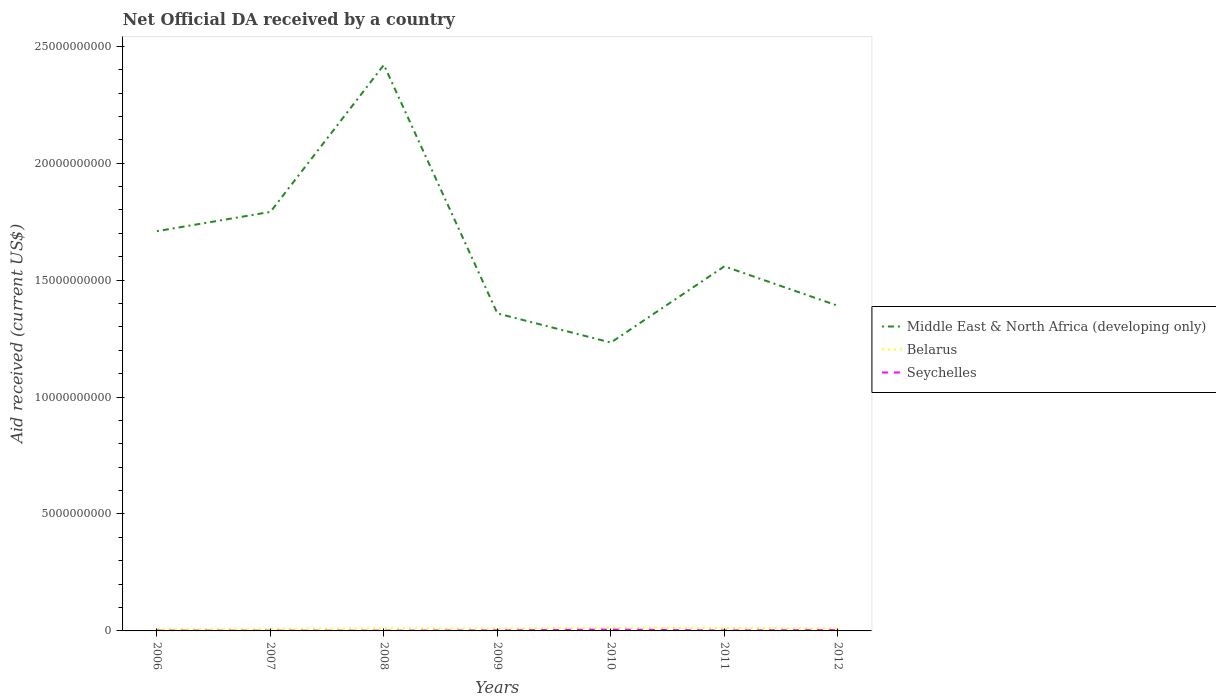How many different coloured lines are there?
Provide a succinct answer. 3. Is the number of lines equal to the number of legend labels?
Ensure brevity in your answer.  Yes. Across all years, what is the maximum net official development assistance aid received in Belarus?
Ensure brevity in your answer.  7.65e+07. What is the total net official development assistance aid received in Belarus in the graph?
Provide a short and direct response. 7.15e+06. What is the difference between the highest and the second highest net official development assistance aid received in Middle East & North Africa (developing only)?
Your answer should be compact. 1.19e+1. Is the net official development assistance aid received in Belarus strictly greater than the net official development assistance aid received in Seychelles over the years?
Make the answer very short. No. What is the difference between two consecutive major ticks on the Y-axis?
Your response must be concise. 5.00e+09. Are the values on the major ticks of Y-axis written in scientific E-notation?
Make the answer very short. No. Does the graph contain any zero values?
Provide a succinct answer. No. How many legend labels are there?
Give a very brief answer. 3. How are the legend labels stacked?
Make the answer very short. Vertical. What is the title of the graph?
Provide a succinct answer. Net Official DA received by a country. Does "Iceland" appear as one of the legend labels in the graph?
Offer a very short reply. No. What is the label or title of the X-axis?
Keep it short and to the point. Years. What is the label or title of the Y-axis?
Your response must be concise. Aid received (current US$). What is the Aid received (current US$) of Middle East & North Africa (developing only) in 2006?
Keep it short and to the point. 1.71e+1. What is the Aid received (current US$) in Belarus in 2006?
Make the answer very short. 7.65e+07. What is the Aid received (current US$) in Seychelles in 2006?
Give a very brief answer. 1.36e+07. What is the Aid received (current US$) of Middle East & North Africa (developing only) in 2007?
Your answer should be compact. 1.79e+1. What is the Aid received (current US$) of Belarus in 2007?
Provide a short and direct response. 8.38e+07. What is the Aid received (current US$) of Seychelles in 2007?
Provide a succinct answer. 1.10e+07. What is the Aid received (current US$) of Middle East & North Africa (developing only) in 2008?
Provide a succinct answer. 2.42e+1. What is the Aid received (current US$) of Belarus in 2008?
Make the answer very short. 1.10e+08. What is the Aid received (current US$) of Seychelles in 2008?
Offer a terse response. 1.25e+07. What is the Aid received (current US$) of Middle East & North Africa (developing only) in 2009?
Your answer should be very brief. 1.36e+1. What is the Aid received (current US$) of Belarus in 2009?
Ensure brevity in your answer.  9.77e+07. What is the Aid received (current US$) of Seychelles in 2009?
Give a very brief answer. 2.28e+07. What is the Aid received (current US$) in Middle East & North Africa (developing only) in 2010?
Keep it short and to the point. 1.23e+1. What is the Aid received (current US$) in Belarus in 2010?
Keep it short and to the point. 1.38e+08. What is the Aid received (current US$) of Seychelles in 2010?
Keep it short and to the point. 5.60e+07. What is the Aid received (current US$) in Middle East & North Africa (developing only) in 2011?
Ensure brevity in your answer.  1.56e+1. What is the Aid received (current US$) in Belarus in 2011?
Your response must be concise. 1.26e+08. What is the Aid received (current US$) of Seychelles in 2011?
Offer a very short reply. 2.21e+07. What is the Aid received (current US$) of Middle East & North Africa (developing only) in 2012?
Your answer should be very brief. 1.39e+1. What is the Aid received (current US$) in Belarus in 2012?
Provide a short and direct response. 1.03e+08. What is the Aid received (current US$) in Seychelles in 2012?
Provide a succinct answer. 3.56e+07. Across all years, what is the maximum Aid received (current US$) of Middle East & North Africa (developing only)?
Provide a succinct answer. 2.42e+1. Across all years, what is the maximum Aid received (current US$) of Belarus?
Provide a short and direct response. 1.38e+08. Across all years, what is the maximum Aid received (current US$) in Seychelles?
Your answer should be very brief. 5.60e+07. Across all years, what is the minimum Aid received (current US$) of Middle East & North Africa (developing only)?
Your answer should be very brief. 1.23e+1. Across all years, what is the minimum Aid received (current US$) in Belarus?
Ensure brevity in your answer.  7.65e+07. Across all years, what is the minimum Aid received (current US$) of Seychelles?
Give a very brief answer. 1.10e+07. What is the total Aid received (current US$) of Middle East & North Africa (developing only) in the graph?
Your answer should be very brief. 1.15e+11. What is the total Aid received (current US$) of Belarus in the graph?
Ensure brevity in your answer.  7.36e+08. What is the total Aid received (current US$) in Seychelles in the graph?
Provide a succinct answer. 1.74e+08. What is the difference between the Aid received (current US$) of Middle East & North Africa (developing only) in 2006 and that in 2007?
Provide a succinct answer. -8.23e+08. What is the difference between the Aid received (current US$) in Belarus in 2006 and that in 2007?
Your response must be concise. -7.24e+06. What is the difference between the Aid received (current US$) of Seychelles in 2006 and that in 2007?
Offer a very short reply. 2.60e+06. What is the difference between the Aid received (current US$) in Middle East & North Africa (developing only) in 2006 and that in 2008?
Offer a terse response. -7.11e+09. What is the difference between the Aid received (current US$) of Belarus in 2006 and that in 2008?
Offer a very short reply. -3.39e+07. What is the difference between the Aid received (current US$) of Seychelles in 2006 and that in 2008?
Your response must be concise. 1.12e+06. What is the difference between the Aid received (current US$) of Middle East & North Africa (developing only) in 2006 and that in 2009?
Your response must be concise. 3.52e+09. What is the difference between the Aid received (current US$) of Belarus in 2006 and that in 2009?
Keep it short and to the point. -2.11e+07. What is the difference between the Aid received (current US$) of Seychelles in 2006 and that in 2009?
Provide a short and direct response. -9.12e+06. What is the difference between the Aid received (current US$) in Middle East & North Africa (developing only) in 2006 and that in 2010?
Ensure brevity in your answer.  4.76e+09. What is the difference between the Aid received (current US$) of Belarus in 2006 and that in 2010?
Make the answer very short. -6.16e+07. What is the difference between the Aid received (current US$) of Seychelles in 2006 and that in 2010?
Make the answer very short. -4.24e+07. What is the difference between the Aid received (current US$) in Middle East & North Africa (developing only) in 2006 and that in 2011?
Ensure brevity in your answer.  1.50e+09. What is the difference between the Aid received (current US$) of Belarus in 2006 and that in 2011?
Provide a succinct answer. -4.95e+07. What is the difference between the Aid received (current US$) of Seychelles in 2006 and that in 2011?
Provide a short and direct response. -8.46e+06. What is the difference between the Aid received (current US$) in Middle East & North Africa (developing only) in 2006 and that in 2012?
Your response must be concise. 3.19e+09. What is the difference between the Aid received (current US$) of Belarus in 2006 and that in 2012?
Give a very brief answer. -2.68e+07. What is the difference between the Aid received (current US$) of Seychelles in 2006 and that in 2012?
Keep it short and to the point. -2.19e+07. What is the difference between the Aid received (current US$) in Middle East & North Africa (developing only) in 2007 and that in 2008?
Offer a very short reply. -6.29e+09. What is the difference between the Aid received (current US$) of Belarus in 2007 and that in 2008?
Provide a succinct answer. -2.67e+07. What is the difference between the Aid received (current US$) in Seychelles in 2007 and that in 2008?
Ensure brevity in your answer.  -1.48e+06. What is the difference between the Aid received (current US$) of Middle East & North Africa (developing only) in 2007 and that in 2009?
Make the answer very short. 4.34e+09. What is the difference between the Aid received (current US$) of Belarus in 2007 and that in 2009?
Your answer should be compact. -1.39e+07. What is the difference between the Aid received (current US$) of Seychelles in 2007 and that in 2009?
Give a very brief answer. -1.17e+07. What is the difference between the Aid received (current US$) in Middle East & North Africa (developing only) in 2007 and that in 2010?
Offer a terse response. 5.59e+09. What is the difference between the Aid received (current US$) in Belarus in 2007 and that in 2010?
Keep it short and to the point. -5.44e+07. What is the difference between the Aid received (current US$) in Seychelles in 2007 and that in 2010?
Give a very brief answer. -4.50e+07. What is the difference between the Aid received (current US$) of Middle East & North Africa (developing only) in 2007 and that in 2011?
Give a very brief answer. 2.33e+09. What is the difference between the Aid received (current US$) of Belarus in 2007 and that in 2011?
Your answer should be compact. -4.22e+07. What is the difference between the Aid received (current US$) in Seychelles in 2007 and that in 2011?
Offer a very short reply. -1.11e+07. What is the difference between the Aid received (current US$) in Middle East & North Africa (developing only) in 2007 and that in 2012?
Keep it short and to the point. 4.01e+09. What is the difference between the Aid received (current US$) of Belarus in 2007 and that in 2012?
Your answer should be compact. -1.95e+07. What is the difference between the Aid received (current US$) in Seychelles in 2007 and that in 2012?
Offer a very short reply. -2.45e+07. What is the difference between the Aid received (current US$) of Middle East & North Africa (developing only) in 2008 and that in 2009?
Keep it short and to the point. 1.06e+1. What is the difference between the Aid received (current US$) of Belarus in 2008 and that in 2009?
Your response must be concise. 1.28e+07. What is the difference between the Aid received (current US$) in Seychelles in 2008 and that in 2009?
Offer a terse response. -1.02e+07. What is the difference between the Aid received (current US$) in Middle East & North Africa (developing only) in 2008 and that in 2010?
Give a very brief answer. 1.19e+1. What is the difference between the Aid received (current US$) of Belarus in 2008 and that in 2010?
Your response must be concise. -2.77e+07. What is the difference between the Aid received (current US$) of Seychelles in 2008 and that in 2010?
Provide a short and direct response. -4.35e+07. What is the difference between the Aid received (current US$) of Middle East & North Africa (developing only) in 2008 and that in 2011?
Offer a terse response. 8.62e+09. What is the difference between the Aid received (current US$) in Belarus in 2008 and that in 2011?
Your answer should be compact. -1.56e+07. What is the difference between the Aid received (current US$) of Seychelles in 2008 and that in 2011?
Provide a succinct answer. -9.58e+06. What is the difference between the Aid received (current US$) of Middle East & North Africa (developing only) in 2008 and that in 2012?
Offer a very short reply. 1.03e+1. What is the difference between the Aid received (current US$) in Belarus in 2008 and that in 2012?
Give a very brief answer. 7.15e+06. What is the difference between the Aid received (current US$) of Seychelles in 2008 and that in 2012?
Make the answer very short. -2.31e+07. What is the difference between the Aid received (current US$) in Middle East & North Africa (developing only) in 2009 and that in 2010?
Provide a short and direct response. 1.25e+09. What is the difference between the Aid received (current US$) of Belarus in 2009 and that in 2010?
Your response must be concise. -4.04e+07. What is the difference between the Aid received (current US$) in Seychelles in 2009 and that in 2010?
Keep it short and to the point. -3.33e+07. What is the difference between the Aid received (current US$) in Middle East & North Africa (developing only) in 2009 and that in 2011?
Offer a very short reply. -2.01e+09. What is the difference between the Aid received (current US$) of Belarus in 2009 and that in 2011?
Offer a terse response. -2.83e+07. What is the difference between the Aid received (current US$) in Middle East & North Africa (developing only) in 2009 and that in 2012?
Make the answer very short. -3.27e+08. What is the difference between the Aid received (current US$) in Belarus in 2009 and that in 2012?
Give a very brief answer. -5.61e+06. What is the difference between the Aid received (current US$) in Seychelles in 2009 and that in 2012?
Offer a terse response. -1.28e+07. What is the difference between the Aid received (current US$) in Middle East & North Africa (developing only) in 2010 and that in 2011?
Give a very brief answer. -3.26e+09. What is the difference between the Aid received (current US$) of Belarus in 2010 and that in 2011?
Keep it short and to the point. 1.21e+07. What is the difference between the Aid received (current US$) in Seychelles in 2010 and that in 2011?
Offer a very short reply. 3.39e+07. What is the difference between the Aid received (current US$) in Middle East & North Africa (developing only) in 2010 and that in 2012?
Keep it short and to the point. -1.57e+09. What is the difference between the Aid received (current US$) in Belarus in 2010 and that in 2012?
Your response must be concise. 3.48e+07. What is the difference between the Aid received (current US$) of Seychelles in 2010 and that in 2012?
Your response must be concise. 2.05e+07. What is the difference between the Aid received (current US$) of Middle East & North Africa (developing only) in 2011 and that in 2012?
Provide a short and direct response. 1.69e+09. What is the difference between the Aid received (current US$) in Belarus in 2011 and that in 2012?
Give a very brief answer. 2.27e+07. What is the difference between the Aid received (current US$) of Seychelles in 2011 and that in 2012?
Offer a very short reply. -1.35e+07. What is the difference between the Aid received (current US$) of Middle East & North Africa (developing only) in 2006 and the Aid received (current US$) of Belarus in 2007?
Keep it short and to the point. 1.70e+1. What is the difference between the Aid received (current US$) of Middle East & North Africa (developing only) in 2006 and the Aid received (current US$) of Seychelles in 2007?
Your answer should be very brief. 1.71e+1. What is the difference between the Aid received (current US$) of Belarus in 2006 and the Aid received (current US$) of Seychelles in 2007?
Provide a short and direct response. 6.55e+07. What is the difference between the Aid received (current US$) of Middle East & North Africa (developing only) in 2006 and the Aid received (current US$) of Belarus in 2008?
Offer a very short reply. 1.70e+1. What is the difference between the Aid received (current US$) of Middle East & North Africa (developing only) in 2006 and the Aid received (current US$) of Seychelles in 2008?
Keep it short and to the point. 1.71e+1. What is the difference between the Aid received (current US$) of Belarus in 2006 and the Aid received (current US$) of Seychelles in 2008?
Your answer should be very brief. 6.40e+07. What is the difference between the Aid received (current US$) of Middle East & North Africa (developing only) in 2006 and the Aid received (current US$) of Belarus in 2009?
Your response must be concise. 1.70e+1. What is the difference between the Aid received (current US$) in Middle East & North Africa (developing only) in 2006 and the Aid received (current US$) in Seychelles in 2009?
Offer a terse response. 1.71e+1. What is the difference between the Aid received (current US$) of Belarus in 2006 and the Aid received (current US$) of Seychelles in 2009?
Ensure brevity in your answer.  5.38e+07. What is the difference between the Aid received (current US$) in Middle East & North Africa (developing only) in 2006 and the Aid received (current US$) in Belarus in 2010?
Provide a succinct answer. 1.70e+1. What is the difference between the Aid received (current US$) of Middle East & North Africa (developing only) in 2006 and the Aid received (current US$) of Seychelles in 2010?
Provide a short and direct response. 1.70e+1. What is the difference between the Aid received (current US$) in Belarus in 2006 and the Aid received (current US$) in Seychelles in 2010?
Offer a terse response. 2.05e+07. What is the difference between the Aid received (current US$) of Middle East & North Africa (developing only) in 2006 and the Aid received (current US$) of Belarus in 2011?
Keep it short and to the point. 1.70e+1. What is the difference between the Aid received (current US$) of Middle East & North Africa (developing only) in 2006 and the Aid received (current US$) of Seychelles in 2011?
Give a very brief answer. 1.71e+1. What is the difference between the Aid received (current US$) of Belarus in 2006 and the Aid received (current US$) of Seychelles in 2011?
Make the answer very short. 5.44e+07. What is the difference between the Aid received (current US$) of Middle East & North Africa (developing only) in 2006 and the Aid received (current US$) of Belarus in 2012?
Offer a very short reply. 1.70e+1. What is the difference between the Aid received (current US$) in Middle East & North Africa (developing only) in 2006 and the Aid received (current US$) in Seychelles in 2012?
Your answer should be compact. 1.71e+1. What is the difference between the Aid received (current US$) of Belarus in 2006 and the Aid received (current US$) of Seychelles in 2012?
Give a very brief answer. 4.09e+07. What is the difference between the Aid received (current US$) of Middle East & North Africa (developing only) in 2007 and the Aid received (current US$) of Belarus in 2008?
Ensure brevity in your answer.  1.78e+1. What is the difference between the Aid received (current US$) in Middle East & North Africa (developing only) in 2007 and the Aid received (current US$) in Seychelles in 2008?
Provide a short and direct response. 1.79e+1. What is the difference between the Aid received (current US$) in Belarus in 2007 and the Aid received (current US$) in Seychelles in 2008?
Your answer should be very brief. 7.12e+07. What is the difference between the Aid received (current US$) of Middle East & North Africa (developing only) in 2007 and the Aid received (current US$) of Belarus in 2009?
Provide a succinct answer. 1.78e+1. What is the difference between the Aid received (current US$) of Middle East & North Africa (developing only) in 2007 and the Aid received (current US$) of Seychelles in 2009?
Your response must be concise. 1.79e+1. What is the difference between the Aid received (current US$) in Belarus in 2007 and the Aid received (current US$) in Seychelles in 2009?
Make the answer very short. 6.10e+07. What is the difference between the Aid received (current US$) of Middle East & North Africa (developing only) in 2007 and the Aid received (current US$) of Belarus in 2010?
Provide a short and direct response. 1.78e+1. What is the difference between the Aid received (current US$) in Middle East & North Africa (developing only) in 2007 and the Aid received (current US$) in Seychelles in 2010?
Offer a terse response. 1.79e+1. What is the difference between the Aid received (current US$) in Belarus in 2007 and the Aid received (current US$) in Seychelles in 2010?
Ensure brevity in your answer.  2.77e+07. What is the difference between the Aid received (current US$) in Middle East & North Africa (developing only) in 2007 and the Aid received (current US$) in Belarus in 2011?
Ensure brevity in your answer.  1.78e+1. What is the difference between the Aid received (current US$) in Middle East & North Africa (developing only) in 2007 and the Aid received (current US$) in Seychelles in 2011?
Provide a succinct answer. 1.79e+1. What is the difference between the Aid received (current US$) of Belarus in 2007 and the Aid received (current US$) of Seychelles in 2011?
Your answer should be compact. 6.17e+07. What is the difference between the Aid received (current US$) in Middle East & North Africa (developing only) in 2007 and the Aid received (current US$) in Belarus in 2012?
Provide a short and direct response. 1.78e+1. What is the difference between the Aid received (current US$) of Middle East & North Africa (developing only) in 2007 and the Aid received (current US$) of Seychelles in 2012?
Make the answer very short. 1.79e+1. What is the difference between the Aid received (current US$) in Belarus in 2007 and the Aid received (current US$) in Seychelles in 2012?
Provide a succinct answer. 4.82e+07. What is the difference between the Aid received (current US$) in Middle East & North Africa (developing only) in 2008 and the Aid received (current US$) in Belarus in 2009?
Offer a very short reply. 2.41e+1. What is the difference between the Aid received (current US$) of Middle East & North Africa (developing only) in 2008 and the Aid received (current US$) of Seychelles in 2009?
Provide a succinct answer. 2.42e+1. What is the difference between the Aid received (current US$) in Belarus in 2008 and the Aid received (current US$) in Seychelles in 2009?
Ensure brevity in your answer.  8.77e+07. What is the difference between the Aid received (current US$) of Middle East & North Africa (developing only) in 2008 and the Aid received (current US$) of Belarus in 2010?
Your response must be concise. 2.41e+1. What is the difference between the Aid received (current US$) in Middle East & North Africa (developing only) in 2008 and the Aid received (current US$) in Seychelles in 2010?
Your answer should be compact. 2.41e+1. What is the difference between the Aid received (current US$) in Belarus in 2008 and the Aid received (current US$) in Seychelles in 2010?
Make the answer very short. 5.44e+07. What is the difference between the Aid received (current US$) of Middle East & North Africa (developing only) in 2008 and the Aid received (current US$) of Belarus in 2011?
Keep it short and to the point. 2.41e+1. What is the difference between the Aid received (current US$) of Middle East & North Africa (developing only) in 2008 and the Aid received (current US$) of Seychelles in 2011?
Your answer should be very brief. 2.42e+1. What is the difference between the Aid received (current US$) of Belarus in 2008 and the Aid received (current US$) of Seychelles in 2011?
Ensure brevity in your answer.  8.83e+07. What is the difference between the Aid received (current US$) in Middle East & North Africa (developing only) in 2008 and the Aid received (current US$) in Belarus in 2012?
Provide a succinct answer. 2.41e+1. What is the difference between the Aid received (current US$) of Middle East & North Africa (developing only) in 2008 and the Aid received (current US$) of Seychelles in 2012?
Your answer should be compact. 2.42e+1. What is the difference between the Aid received (current US$) in Belarus in 2008 and the Aid received (current US$) in Seychelles in 2012?
Make the answer very short. 7.48e+07. What is the difference between the Aid received (current US$) of Middle East & North Africa (developing only) in 2009 and the Aid received (current US$) of Belarus in 2010?
Offer a terse response. 1.34e+1. What is the difference between the Aid received (current US$) of Middle East & North Africa (developing only) in 2009 and the Aid received (current US$) of Seychelles in 2010?
Give a very brief answer. 1.35e+1. What is the difference between the Aid received (current US$) of Belarus in 2009 and the Aid received (current US$) of Seychelles in 2010?
Make the answer very short. 4.16e+07. What is the difference between the Aid received (current US$) of Middle East & North Africa (developing only) in 2009 and the Aid received (current US$) of Belarus in 2011?
Your answer should be compact. 1.35e+1. What is the difference between the Aid received (current US$) of Middle East & North Africa (developing only) in 2009 and the Aid received (current US$) of Seychelles in 2011?
Your answer should be compact. 1.36e+1. What is the difference between the Aid received (current US$) of Belarus in 2009 and the Aid received (current US$) of Seychelles in 2011?
Keep it short and to the point. 7.56e+07. What is the difference between the Aid received (current US$) of Middle East & North Africa (developing only) in 2009 and the Aid received (current US$) of Belarus in 2012?
Make the answer very short. 1.35e+1. What is the difference between the Aid received (current US$) in Middle East & North Africa (developing only) in 2009 and the Aid received (current US$) in Seychelles in 2012?
Keep it short and to the point. 1.35e+1. What is the difference between the Aid received (current US$) in Belarus in 2009 and the Aid received (current US$) in Seychelles in 2012?
Keep it short and to the point. 6.21e+07. What is the difference between the Aid received (current US$) of Middle East & North Africa (developing only) in 2010 and the Aid received (current US$) of Belarus in 2011?
Your answer should be compact. 1.22e+1. What is the difference between the Aid received (current US$) of Middle East & North Africa (developing only) in 2010 and the Aid received (current US$) of Seychelles in 2011?
Your answer should be compact. 1.23e+1. What is the difference between the Aid received (current US$) of Belarus in 2010 and the Aid received (current US$) of Seychelles in 2011?
Provide a succinct answer. 1.16e+08. What is the difference between the Aid received (current US$) in Middle East & North Africa (developing only) in 2010 and the Aid received (current US$) in Belarus in 2012?
Offer a very short reply. 1.22e+1. What is the difference between the Aid received (current US$) of Middle East & North Africa (developing only) in 2010 and the Aid received (current US$) of Seychelles in 2012?
Provide a short and direct response. 1.23e+1. What is the difference between the Aid received (current US$) in Belarus in 2010 and the Aid received (current US$) in Seychelles in 2012?
Offer a very short reply. 1.03e+08. What is the difference between the Aid received (current US$) of Middle East & North Africa (developing only) in 2011 and the Aid received (current US$) of Belarus in 2012?
Keep it short and to the point. 1.55e+1. What is the difference between the Aid received (current US$) in Middle East & North Africa (developing only) in 2011 and the Aid received (current US$) in Seychelles in 2012?
Offer a terse response. 1.56e+1. What is the difference between the Aid received (current US$) of Belarus in 2011 and the Aid received (current US$) of Seychelles in 2012?
Give a very brief answer. 9.04e+07. What is the average Aid received (current US$) of Middle East & North Africa (developing only) per year?
Your answer should be compact. 1.64e+1. What is the average Aid received (current US$) of Belarus per year?
Ensure brevity in your answer.  1.05e+08. What is the average Aid received (current US$) in Seychelles per year?
Your answer should be compact. 2.48e+07. In the year 2006, what is the difference between the Aid received (current US$) in Middle East & North Africa (developing only) and Aid received (current US$) in Belarus?
Your answer should be compact. 1.70e+1. In the year 2006, what is the difference between the Aid received (current US$) in Middle East & North Africa (developing only) and Aid received (current US$) in Seychelles?
Ensure brevity in your answer.  1.71e+1. In the year 2006, what is the difference between the Aid received (current US$) in Belarus and Aid received (current US$) in Seychelles?
Provide a succinct answer. 6.29e+07. In the year 2007, what is the difference between the Aid received (current US$) in Middle East & North Africa (developing only) and Aid received (current US$) in Belarus?
Keep it short and to the point. 1.78e+1. In the year 2007, what is the difference between the Aid received (current US$) of Middle East & North Africa (developing only) and Aid received (current US$) of Seychelles?
Provide a succinct answer. 1.79e+1. In the year 2007, what is the difference between the Aid received (current US$) in Belarus and Aid received (current US$) in Seychelles?
Your answer should be compact. 7.27e+07. In the year 2008, what is the difference between the Aid received (current US$) in Middle East & North Africa (developing only) and Aid received (current US$) in Belarus?
Your answer should be very brief. 2.41e+1. In the year 2008, what is the difference between the Aid received (current US$) in Middle East & North Africa (developing only) and Aid received (current US$) in Seychelles?
Ensure brevity in your answer.  2.42e+1. In the year 2008, what is the difference between the Aid received (current US$) in Belarus and Aid received (current US$) in Seychelles?
Offer a very short reply. 9.79e+07. In the year 2009, what is the difference between the Aid received (current US$) of Middle East & North Africa (developing only) and Aid received (current US$) of Belarus?
Offer a very short reply. 1.35e+1. In the year 2009, what is the difference between the Aid received (current US$) of Middle East & North Africa (developing only) and Aid received (current US$) of Seychelles?
Keep it short and to the point. 1.36e+1. In the year 2009, what is the difference between the Aid received (current US$) of Belarus and Aid received (current US$) of Seychelles?
Provide a succinct answer. 7.49e+07. In the year 2010, what is the difference between the Aid received (current US$) in Middle East & North Africa (developing only) and Aid received (current US$) in Belarus?
Ensure brevity in your answer.  1.22e+1. In the year 2010, what is the difference between the Aid received (current US$) in Middle East & North Africa (developing only) and Aid received (current US$) in Seychelles?
Provide a succinct answer. 1.23e+1. In the year 2010, what is the difference between the Aid received (current US$) of Belarus and Aid received (current US$) of Seychelles?
Provide a succinct answer. 8.21e+07. In the year 2011, what is the difference between the Aid received (current US$) of Middle East & North Africa (developing only) and Aid received (current US$) of Belarus?
Your answer should be compact. 1.55e+1. In the year 2011, what is the difference between the Aid received (current US$) of Middle East & North Africa (developing only) and Aid received (current US$) of Seychelles?
Ensure brevity in your answer.  1.56e+1. In the year 2011, what is the difference between the Aid received (current US$) of Belarus and Aid received (current US$) of Seychelles?
Your answer should be very brief. 1.04e+08. In the year 2012, what is the difference between the Aid received (current US$) in Middle East & North Africa (developing only) and Aid received (current US$) in Belarus?
Keep it short and to the point. 1.38e+1. In the year 2012, what is the difference between the Aid received (current US$) in Middle East & North Africa (developing only) and Aid received (current US$) in Seychelles?
Give a very brief answer. 1.39e+1. In the year 2012, what is the difference between the Aid received (current US$) of Belarus and Aid received (current US$) of Seychelles?
Make the answer very short. 6.77e+07. What is the ratio of the Aid received (current US$) in Middle East & North Africa (developing only) in 2006 to that in 2007?
Your answer should be very brief. 0.95. What is the ratio of the Aid received (current US$) in Belarus in 2006 to that in 2007?
Offer a terse response. 0.91. What is the ratio of the Aid received (current US$) of Seychelles in 2006 to that in 2007?
Give a very brief answer. 1.24. What is the ratio of the Aid received (current US$) in Middle East & North Africa (developing only) in 2006 to that in 2008?
Offer a very short reply. 0.71. What is the ratio of the Aid received (current US$) in Belarus in 2006 to that in 2008?
Ensure brevity in your answer.  0.69. What is the ratio of the Aid received (current US$) in Seychelles in 2006 to that in 2008?
Ensure brevity in your answer.  1.09. What is the ratio of the Aid received (current US$) in Middle East & North Africa (developing only) in 2006 to that in 2009?
Provide a succinct answer. 1.26. What is the ratio of the Aid received (current US$) in Belarus in 2006 to that in 2009?
Your answer should be very brief. 0.78. What is the ratio of the Aid received (current US$) in Seychelles in 2006 to that in 2009?
Your response must be concise. 0.6. What is the ratio of the Aid received (current US$) in Middle East & North Africa (developing only) in 2006 to that in 2010?
Provide a short and direct response. 1.39. What is the ratio of the Aid received (current US$) in Belarus in 2006 to that in 2010?
Make the answer very short. 0.55. What is the ratio of the Aid received (current US$) in Seychelles in 2006 to that in 2010?
Give a very brief answer. 0.24. What is the ratio of the Aid received (current US$) in Middle East & North Africa (developing only) in 2006 to that in 2011?
Offer a terse response. 1.1. What is the ratio of the Aid received (current US$) in Belarus in 2006 to that in 2011?
Your response must be concise. 0.61. What is the ratio of the Aid received (current US$) in Seychelles in 2006 to that in 2011?
Offer a terse response. 0.62. What is the ratio of the Aid received (current US$) of Middle East & North Africa (developing only) in 2006 to that in 2012?
Your answer should be very brief. 1.23. What is the ratio of the Aid received (current US$) of Belarus in 2006 to that in 2012?
Keep it short and to the point. 0.74. What is the ratio of the Aid received (current US$) of Seychelles in 2006 to that in 2012?
Give a very brief answer. 0.38. What is the ratio of the Aid received (current US$) of Middle East & North Africa (developing only) in 2007 to that in 2008?
Make the answer very short. 0.74. What is the ratio of the Aid received (current US$) in Belarus in 2007 to that in 2008?
Your answer should be compact. 0.76. What is the ratio of the Aid received (current US$) in Seychelles in 2007 to that in 2008?
Provide a short and direct response. 0.88. What is the ratio of the Aid received (current US$) in Middle East & North Africa (developing only) in 2007 to that in 2009?
Provide a succinct answer. 1.32. What is the ratio of the Aid received (current US$) of Belarus in 2007 to that in 2009?
Provide a short and direct response. 0.86. What is the ratio of the Aid received (current US$) in Seychelles in 2007 to that in 2009?
Your answer should be very brief. 0.49. What is the ratio of the Aid received (current US$) of Middle East & North Africa (developing only) in 2007 to that in 2010?
Offer a very short reply. 1.45. What is the ratio of the Aid received (current US$) in Belarus in 2007 to that in 2010?
Keep it short and to the point. 0.61. What is the ratio of the Aid received (current US$) of Seychelles in 2007 to that in 2010?
Your answer should be very brief. 0.2. What is the ratio of the Aid received (current US$) of Middle East & North Africa (developing only) in 2007 to that in 2011?
Ensure brevity in your answer.  1.15. What is the ratio of the Aid received (current US$) of Belarus in 2007 to that in 2011?
Give a very brief answer. 0.66. What is the ratio of the Aid received (current US$) in Seychelles in 2007 to that in 2011?
Provide a succinct answer. 0.5. What is the ratio of the Aid received (current US$) in Middle East & North Africa (developing only) in 2007 to that in 2012?
Ensure brevity in your answer.  1.29. What is the ratio of the Aid received (current US$) of Belarus in 2007 to that in 2012?
Provide a short and direct response. 0.81. What is the ratio of the Aid received (current US$) of Seychelles in 2007 to that in 2012?
Provide a succinct answer. 0.31. What is the ratio of the Aid received (current US$) in Middle East & North Africa (developing only) in 2008 to that in 2009?
Offer a terse response. 1.78. What is the ratio of the Aid received (current US$) of Belarus in 2008 to that in 2009?
Ensure brevity in your answer.  1.13. What is the ratio of the Aid received (current US$) of Seychelles in 2008 to that in 2009?
Offer a very short reply. 0.55. What is the ratio of the Aid received (current US$) of Middle East & North Africa (developing only) in 2008 to that in 2010?
Your response must be concise. 1.96. What is the ratio of the Aid received (current US$) in Belarus in 2008 to that in 2010?
Provide a short and direct response. 0.8. What is the ratio of the Aid received (current US$) of Seychelles in 2008 to that in 2010?
Ensure brevity in your answer.  0.22. What is the ratio of the Aid received (current US$) of Middle East & North Africa (developing only) in 2008 to that in 2011?
Offer a very short reply. 1.55. What is the ratio of the Aid received (current US$) in Belarus in 2008 to that in 2011?
Offer a very short reply. 0.88. What is the ratio of the Aid received (current US$) of Seychelles in 2008 to that in 2011?
Give a very brief answer. 0.57. What is the ratio of the Aid received (current US$) in Middle East & North Africa (developing only) in 2008 to that in 2012?
Give a very brief answer. 1.74. What is the ratio of the Aid received (current US$) of Belarus in 2008 to that in 2012?
Make the answer very short. 1.07. What is the ratio of the Aid received (current US$) of Seychelles in 2008 to that in 2012?
Ensure brevity in your answer.  0.35. What is the ratio of the Aid received (current US$) of Middle East & North Africa (developing only) in 2009 to that in 2010?
Offer a terse response. 1.1. What is the ratio of the Aid received (current US$) in Belarus in 2009 to that in 2010?
Offer a very short reply. 0.71. What is the ratio of the Aid received (current US$) of Seychelles in 2009 to that in 2010?
Your answer should be compact. 0.41. What is the ratio of the Aid received (current US$) in Middle East & North Africa (developing only) in 2009 to that in 2011?
Your answer should be compact. 0.87. What is the ratio of the Aid received (current US$) in Belarus in 2009 to that in 2011?
Give a very brief answer. 0.78. What is the ratio of the Aid received (current US$) of Seychelles in 2009 to that in 2011?
Give a very brief answer. 1.03. What is the ratio of the Aid received (current US$) of Middle East & North Africa (developing only) in 2009 to that in 2012?
Offer a terse response. 0.98. What is the ratio of the Aid received (current US$) of Belarus in 2009 to that in 2012?
Your response must be concise. 0.95. What is the ratio of the Aid received (current US$) in Seychelles in 2009 to that in 2012?
Your answer should be compact. 0.64. What is the ratio of the Aid received (current US$) of Middle East & North Africa (developing only) in 2010 to that in 2011?
Keep it short and to the point. 0.79. What is the ratio of the Aid received (current US$) of Belarus in 2010 to that in 2011?
Your answer should be very brief. 1.1. What is the ratio of the Aid received (current US$) of Seychelles in 2010 to that in 2011?
Offer a very short reply. 2.54. What is the ratio of the Aid received (current US$) of Middle East & North Africa (developing only) in 2010 to that in 2012?
Provide a succinct answer. 0.89. What is the ratio of the Aid received (current US$) in Belarus in 2010 to that in 2012?
Your response must be concise. 1.34. What is the ratio of the Aid received (current US$) of Seychelles in 2010 to that in 2012?
Ensure brevity in your answer.  1.57. What is the ratio of the Aid received (current US$) in Middle East & North Africa (developing only) in 2011 to that in 2012?
Offer a very short reply. 1.12. What is the ratio of the Aid received (current US$) of Belarus in 2011 to that in 2012?
Offer a very short reply. 1.22. What is the ratio of the Aid received (current US$) of Seychelles in 2011 to that in 2012?
Make the answer very short. 0.62. What is the difference between the highest and the second highest Aid received (current US$) in Middle East & North Africa (developing only)?
Provide a succinct answer. 6.29e+09. What is the difference between the highest and the second highest Aid received (current US$) in Belarus?
Provide a succinct answer. 1.21e+07. What is the difference between the highest and the second highest Aid received (current US$) in Seychelles?
Provide a short and direct response. 2.05e+07. What is the difference between the highest and the lowest Aid received (current US$) of Middle East & North Africa (developing only)?
Make the answer very short. 1.19e+1. What is the difference between the highest and the lowest Aid received (current US$) of Belarus?
Your answer should be compact. 6.16e+07. What is the difference between the highest and the lowest Aid received (current US$) in Seychelles?
Provide a short and direct response. 4.50e+07. 